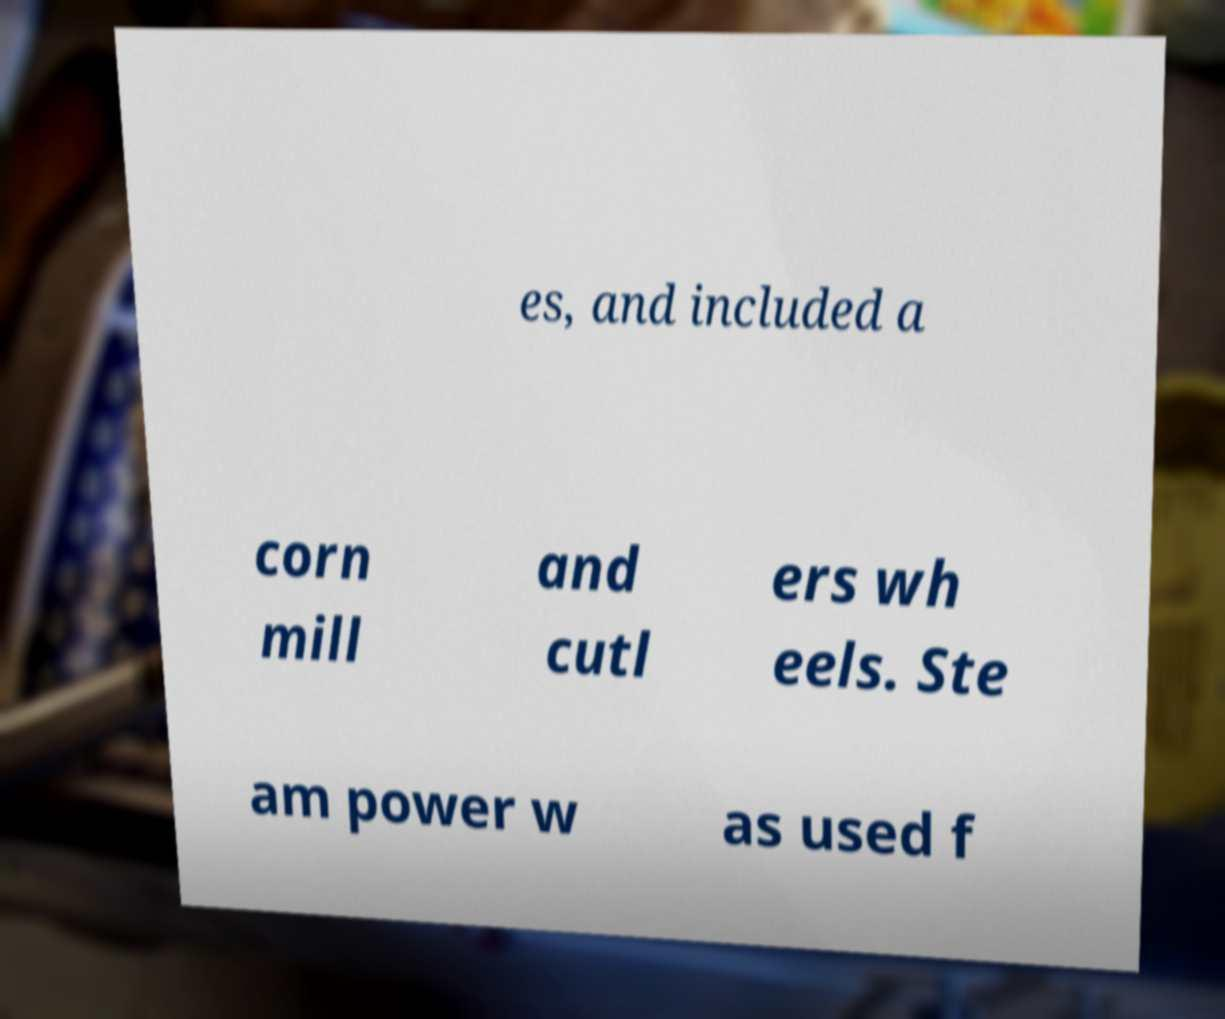Could you assist in decoding the text presented in this image and type it out clearly? es, and included a corn mill and cutl ers wh eels. Ste am power w as used f 